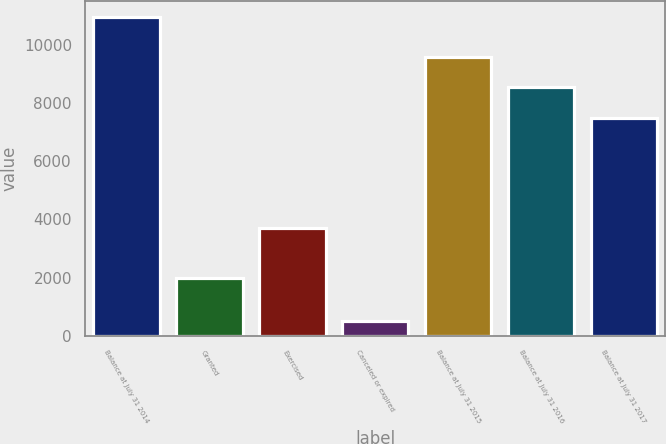<chart> <loc_0><loc_0><loc_500><loc_500><bar_chart><fcel>Balance at July 31 2014<fcel>Granted<fcel>Exercised<fcel>Canceled or expired<fcel>Balance at July 31 2015<fcel>Balance at July 31 2016<fcel>Balance at July 31 2017<nl><fcel>10938<fcel>1981<fcel>3704<fcel>502<fcel>9575.2<fcel>8531.6<fcel>7488<nl></chart> 